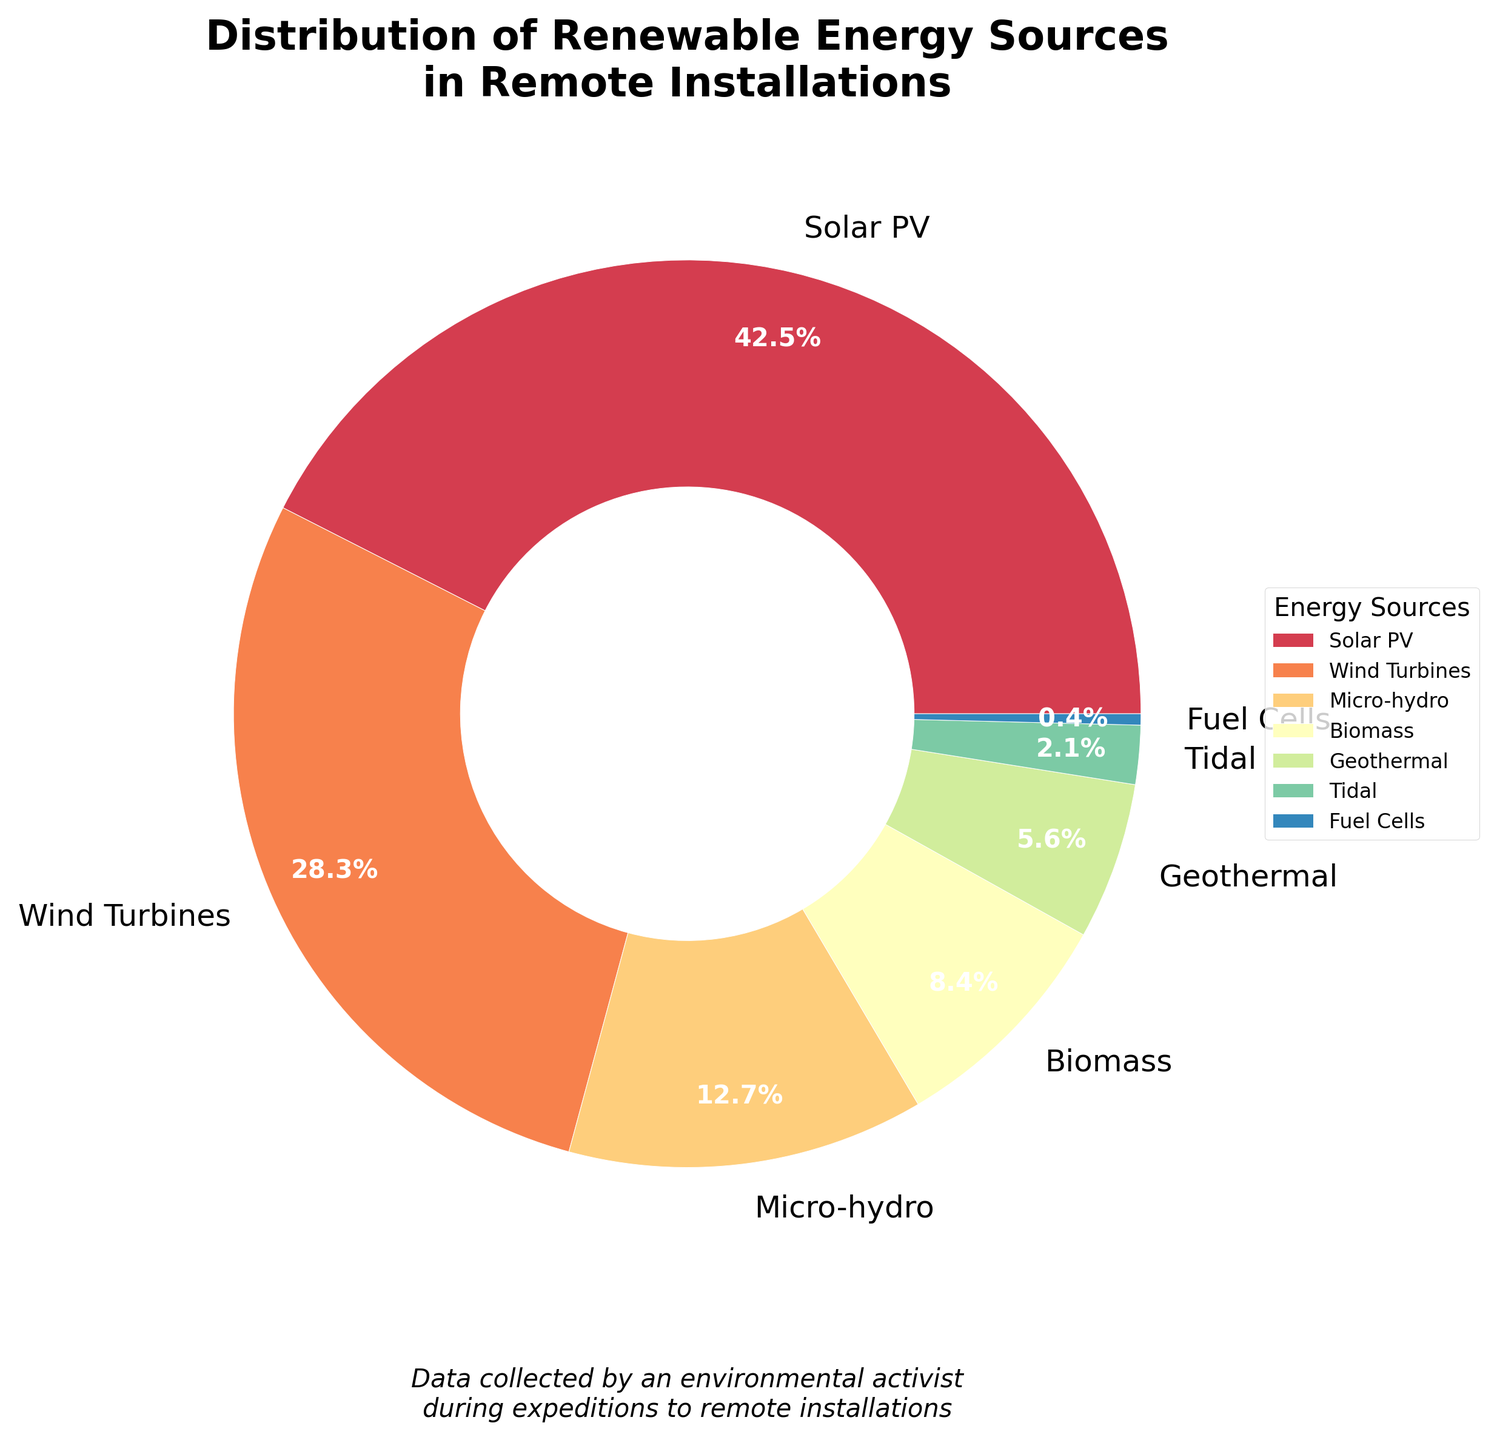What is the largest source of renewable energy in remote installations? Referring to the pie chart, the segment with the largest percentage is labeled Solar PV with 42.5%.
Answer: Solar PV Which renewable energy source has the smallest percentage? The smallest segment in the pie chart corresponds to Fuel Cells, showing a percentage of 0.4%.
Answer: Fuel Cells What is the combined percentage of Wind Turbines and Biomass? Wind Turbines have a percentage of 28.3%, and Biomass has 8.4%. Summing these values gives 28.3 + 8.4 = 36.7%.
Answer: 36.7% How does the percentage of Micro-hydro compare to Geothermal? Micro-hydro is 12.7% and Geothermal is 5.6%. Comparing these values, Micro-hydro is larger than Geothermal.
Answer: Micro-hydro is larger What percentage of renewable energy sources is non-solar (excluding Solar PV)? Exclude Solar PV's 42.5% from 100%. The non-solar percentage is 100 - 42.5 = 57.5%.
Answer: 57.5% Among the listed renewable energy sources, which three sources together occupy approximately 50% of the total distribution? Solar PV (42.5%) and Wind Turbines (28.3%) are the highest, combined they are 42.5 + 28.3 = 70.8%. Adding the next highest, Micro-hydro (12.7%), makes it 70.8 + 12.7 = 83.5%, which is too high. Next, Biomass (8.4%) gives 70.8 + 8.4 = 79.2%, still too high. Finally, Geothermal (5.6%) leads to 70.8 + 5.6 = 76.4%. Only considering Solar PV and Biomass gives 42.5 + 8.4 = 50.9%.
Answer: Solar PV, Wind Turbines, Micro-hydro What is the midpoint percentage between the highest (Solar PV) and the lowest (Fuel Cells) energy sources? The highest percentage is Solar PV at 42.5%, and the lowest is Fuel Cells at 0.4%. The midpoint is (42.5 + 0.4) / 2 = 21.45%.
Answer: 21.45% If Geothermal and Tidal percentages were combined, would they exceed the percentage of Biomass? Geothermal is 5.6% and Tidal is 2.1%. Combined, they are 5.6 + 2.1 = 7.7%. Biomass is 8.4%. Since 7.7% is less than 8.4%, Geothermal and Tidal combined do not exceed Biomass.
Answer: No What color corresponds to the largest segment in the pie chart? The largest segment, Solar PV (42.5%), is represented by a color from the custom color palette used in the figure, typically a bright or contrasting color.
Answer: Bright/contrasting color Which source has a visual representation adjacent to Biomass in the pie chart? Observing the pie chart, segments adjacent to Biomass (8.4%) can be identified as the segments immediately next to Biomass's segment.
Answer: Micro-hydro and Geothermal 